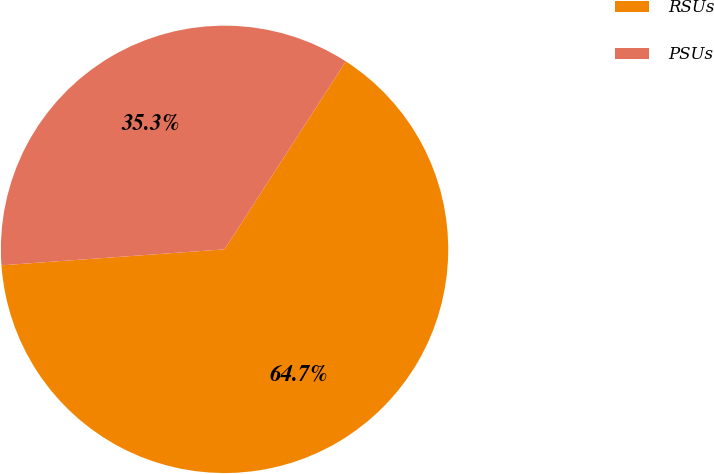Convert chart. <chart><loc_0><loc_0><loc_500><loc_500><pie_chart><fcel>RSUs<fcel>PSUs<nl><fcel>64.74%<fcel>35.26%<nl></chart> 